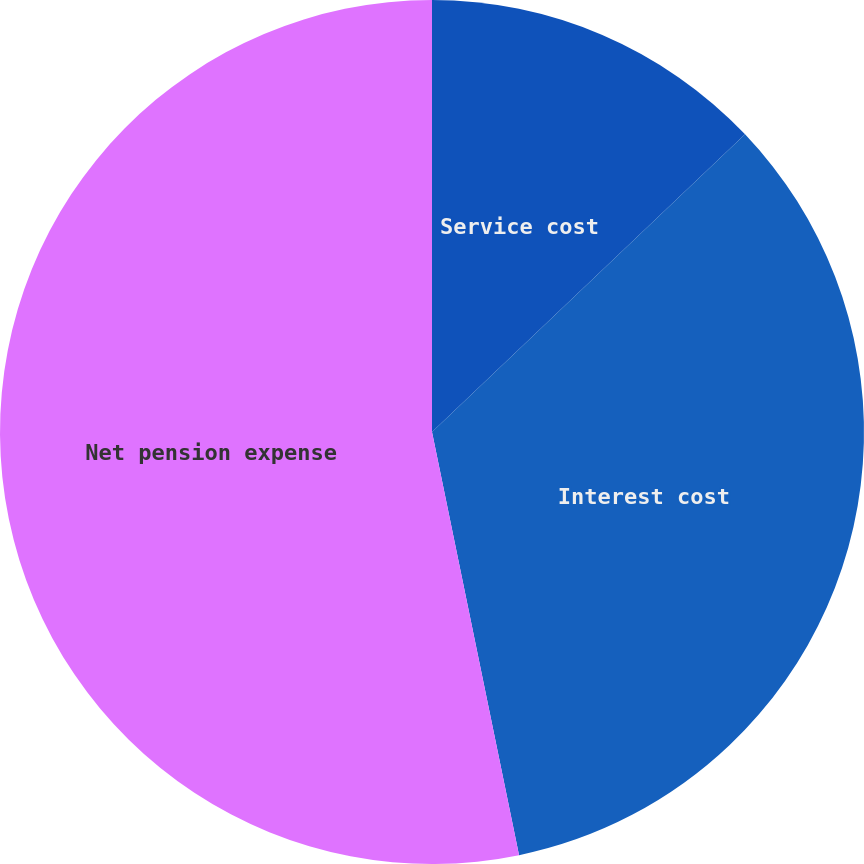<chart> <loc_0><loc_0><loc_500><loc_500><pie_chart><fcel>Service cost<fcel>Interest cost<fcel>Net pension expense<nl><fcel>12.9%<fcel>33.87%<fcel>53.23%<nl></chart> 